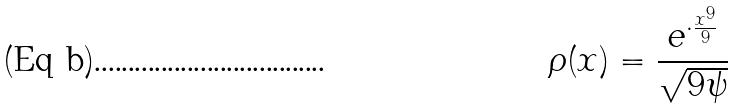Convert formula to latex. <formula><loc_0><loc_0><loc_500><loc_500>\rho ( x ) = \frac { e ^ { \cdot \frac { x ^ { 9 } } { 9 } } } { \sqrt { 9 \psi } }</formula> 